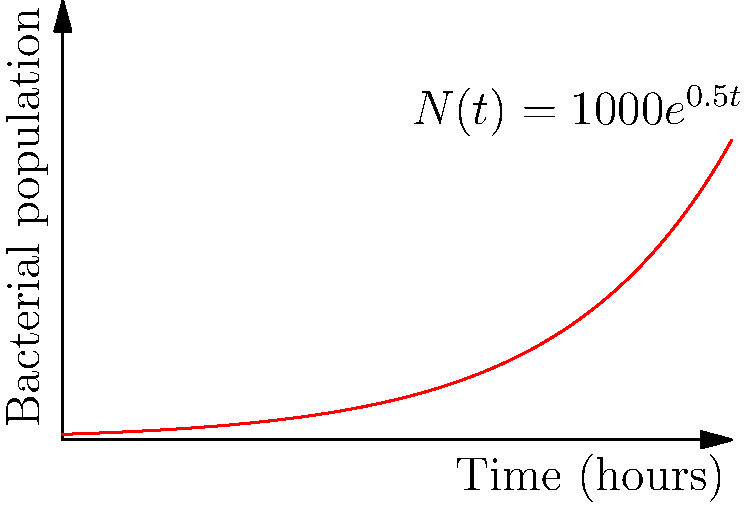A bacterial culture starts with 1000 cells and grows exponentially according to the function $N(t) = 1000e^{0.5t}$, where $N$ is the number of bacteria and $t$ is time in hours. After how many hours will the bacterial population reach 50,000 cells? To solve this problem, we need to follow these steps:

1) We start with the given function: $N(t) = 1000e^{0.5t}$

2) We want to find $t$ when $N(t) = 50,000$. So, we set up the equation:

   $50,000 = 1000e^{0.5t}$

3) Divide both sides by 1000:

   $50 = e^{0.5t}$

4) Take the natural logarithm of both sides:

   $\ln(50) = \ln(e^{0.5t})$

5) Simplify the right side using the properties of logarithms:

   $\ln(50) = 0.5t$

6) Divide both sides by 0.5:

   $\frac{\ln(50)}{0.5} = t$

7) Calculate the value:

   $t = \frac{\ln(50)}{0.5} \approx 7.824$ hours

Therefore, it will take approximately 7.824 hours for the bacterial population to reach 50,000 cells.
Answer: 7.824 hours 